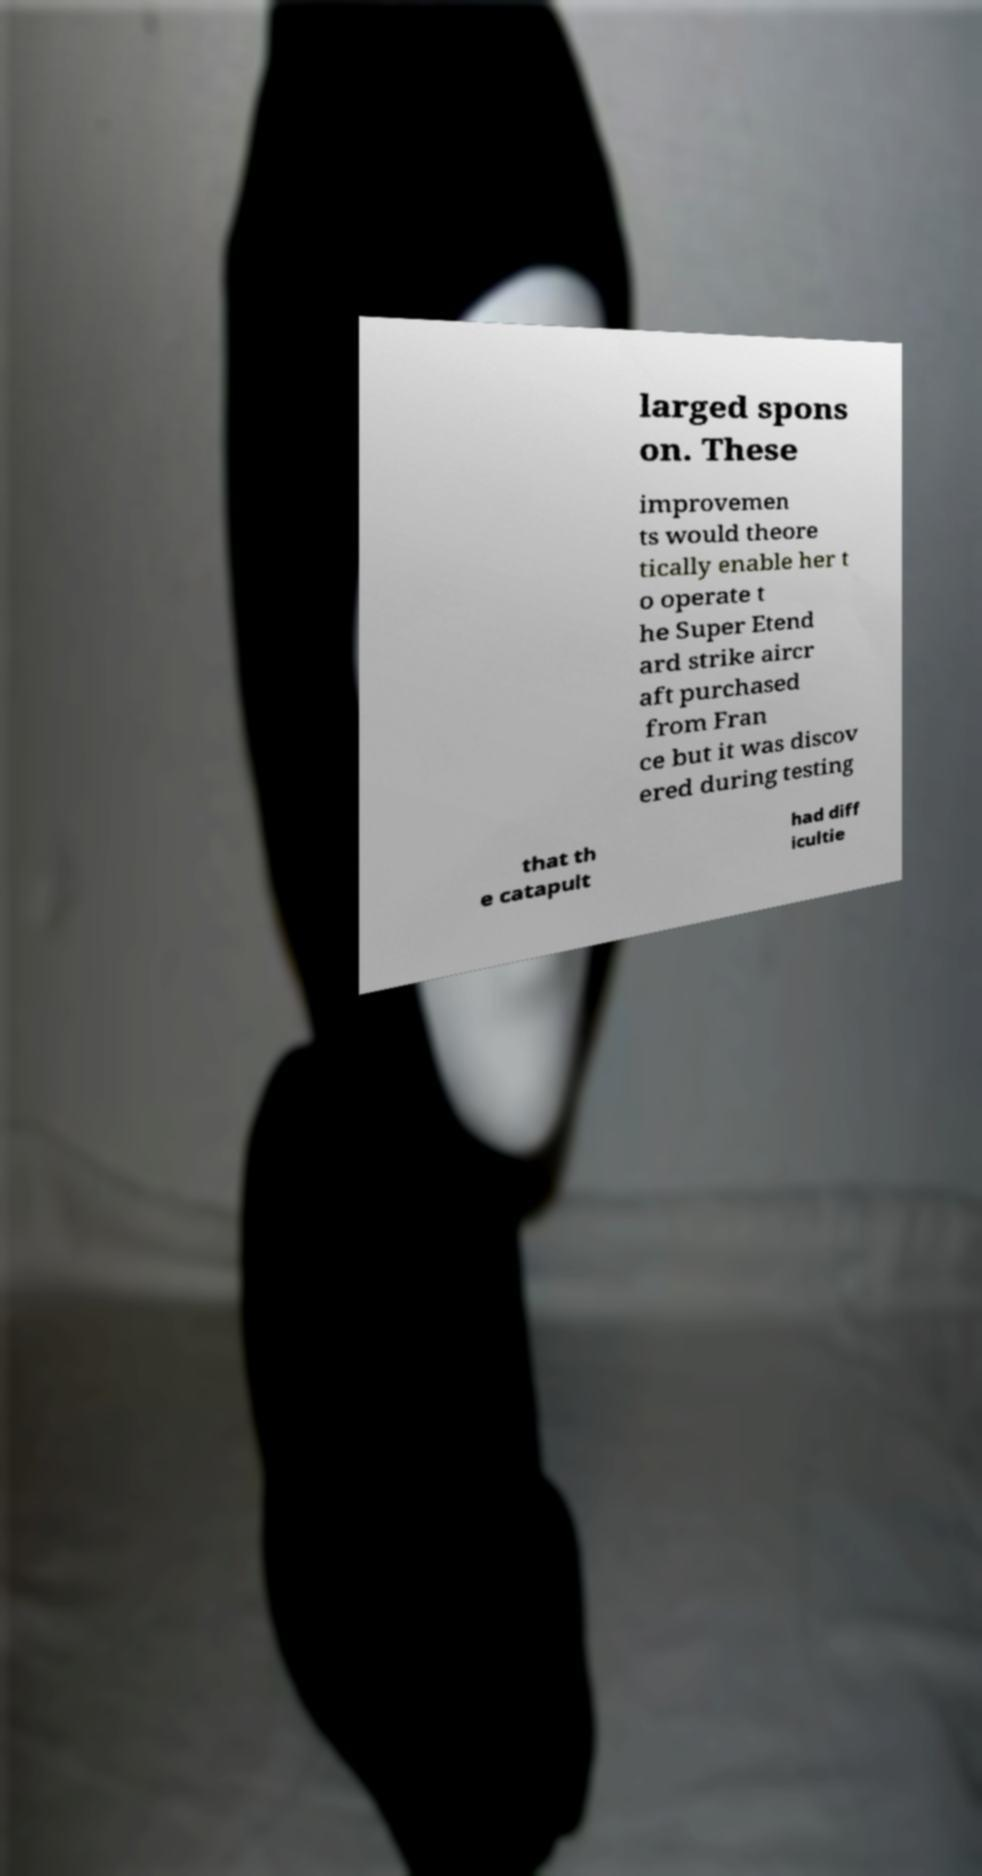Could you assist in decoding the text presented in this image and type it out clearly? larged spons on. These improvemen ts would theore tically enable her t o operate t he Super Etend ard strike aircr aft purchased from Fran ce but it was discov ered during testing that th e catapult had diff icultie 